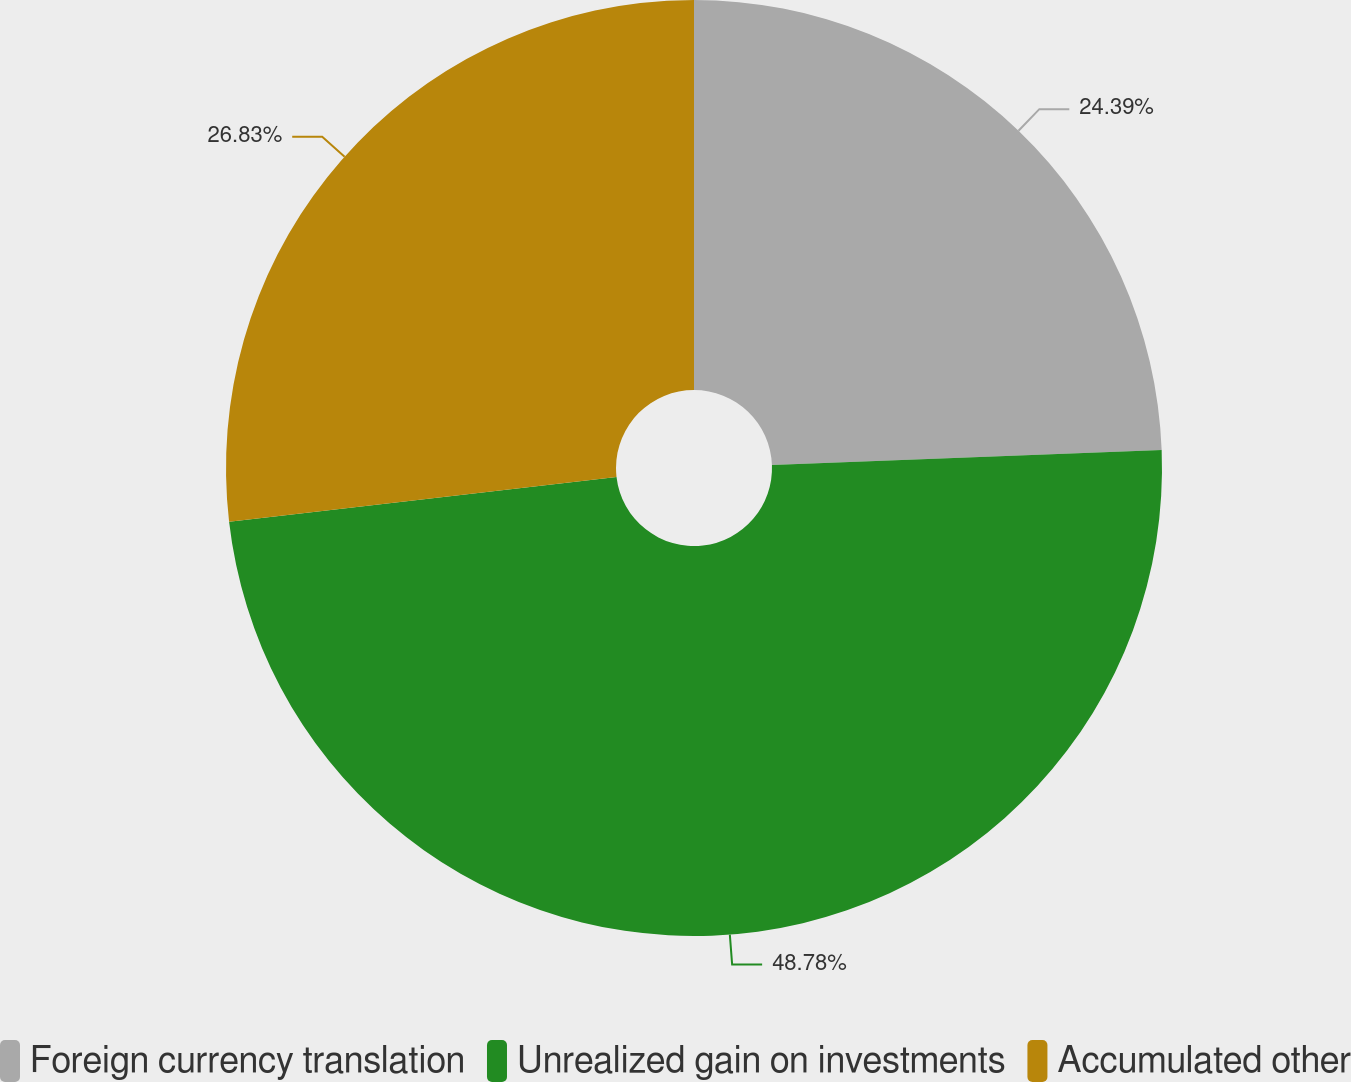Convert chart to OTSL. <chart><loc_0><loc_0><loc_500><loc_500><pie_chart><fcel>Foreign currency translation<fcel>Unrealized gain on investments<fcel>Accumulated other<nl><fcel>24.39%<fcel>48.78%<fcel>26.83%<nl></chart> 